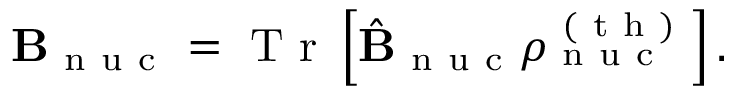<formula> <loc_0><loc_0><loc_500><loc_500>B _ { n u c } = T r \left [ \hat { B } _ { n u c } \rho _ { n u c } ^ { ( t h ) } \right ] .</formula> 